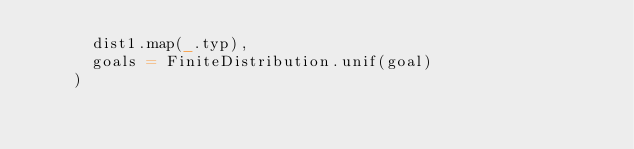<code> <loc_0><loc_0><loc_500><loc_500><_Scala_>      dist1.map(_.typ),
      goals = FiniteDistribution.unif(goal)
    )</code> 